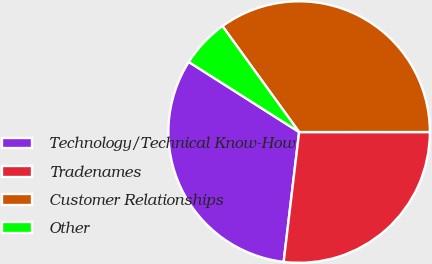Convert chart. <chart><loc_0><loc_0><loc_500><loc_500><pie_chart><fcel>Technology/Technical Know-How<fcel>Tradenames<fcel>Customer Relationships<fcel>Other<nl><fcel>32.12%<fcel>26.89%<fcel>34.97%<fcel>6.02%<nl></chart> 